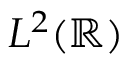Convert formula to latex. <formula><loc_0><loc_0><loc_500><loc_500>L ^ { 2 } ( \mathbb { R } )</formula> 